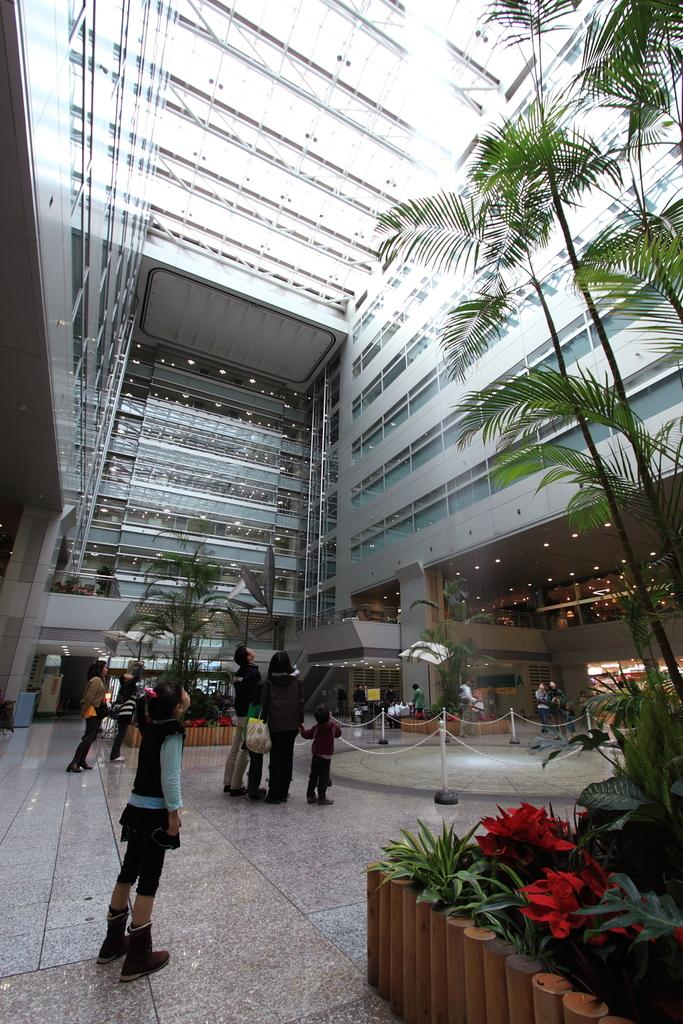What can be seen on the left side of the image? There are people standing on the left side of the image. What are the people doing in the image? The people are looking at the top. What type of vegetation is on the right side of the image? There are plants on the right side of the image. What structure is located at the top of the image? There is a building at the top of the image. What type of rose can be seen on the cake in the image? There is no rose or cake present in the image. What type of blade is being used by the person in the image? There is no blade or person performing an action in the image. 